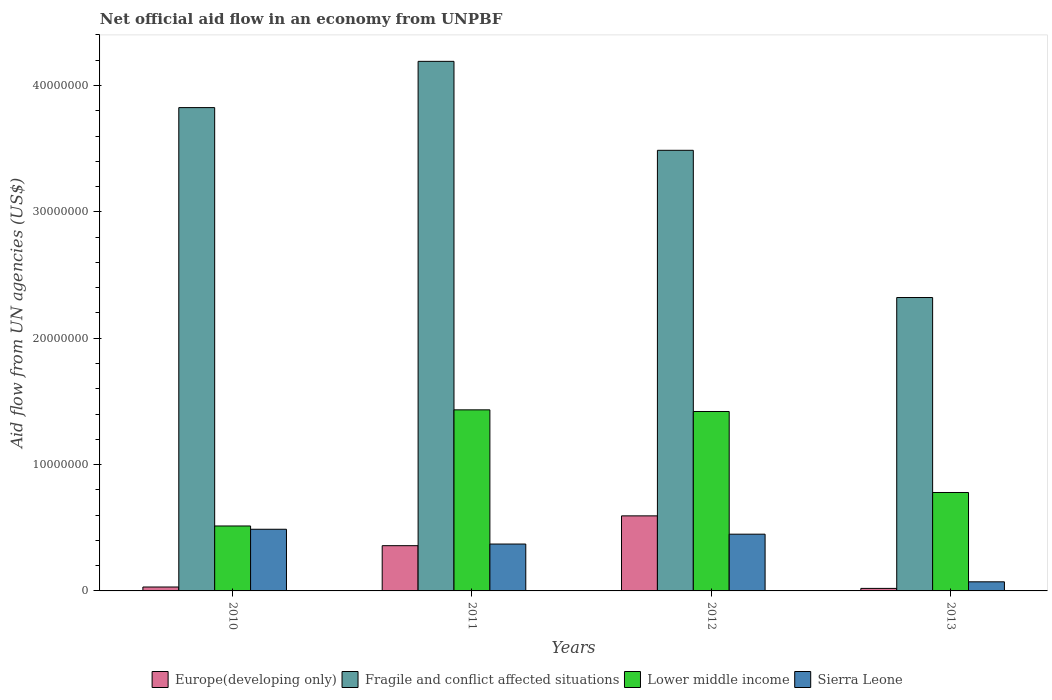How many bars are there on the 1st tick from the right?
Offer a terse response. 4. What is the label of the 4th group of bars from the left?
Offer a terse response. 2013. In how many cases, is the number of bars for a given year not equal to the number of legend labels?
Offer a very short reply. 0. What is the net official aid flow in Lower middle income in 2012?
Ensure brevity in your answer.  1.42e+07. Across all years, what is the maximum net official aid flow in Sierra Leone?
Give a very brief answer. 4.88e+06. Across all years, what is the minimum net official aid flow in Fragile and conflict affected situations?
Make the answer very short. 2.32e+07. What is the total net official aid flow in Lower middle income in the graph?
Make the answer very short. 4.15e+07. What is the difference between the net official aid flow in Lower middle income in 2011 and that in 2013?
Keep it short and to the point. 6.54e+06. What is the difference between the net official aid flow in Europe(developing only) in 2011 and the net official aid flow in Fragile and conflict affected situations in 2010?
Provide a succinct answer. -3.47e+07. What is the average net official aid flow in Fragile and conflict affected situations per year?
Make the answer very short. 3.46e+07. In the year 2013, what is the difference between the net official aid flow in Europe(developing only) and net official aid flow in Sierra Leone?
Offer a terse response. -5.20e+05. In how many years, is the net official aid flow in Sierra Leone greater than 32000000 US$?
Offer a very short reply. 0. What is the ratio of the net official aid flow in Lower middle income in 2012 to that in 2013?
Keep it short and to the point. 1.82. What is the difference between the highest and the lowest net official aid flow in Fragile and conflict affected situations?
Ensure brevity in your answer.  1.87e+07. In how many years, is the net official aid flow in Europe(developing only) greater than the average net official aid flow in Europe(developing only) taken over all years?
Your response must be concise. 2. What does the 2nd bar from the left in 2013 represents?
Your answer should be compact. Fragile and conflict affected situations. What does the 1st bar from the right in 2011 represents?
Keep it short and to the point. Sierra Leone. Is it the case that in every year, the sum of the net official aid flow in Fragile and conflict affected situations and net official aid flow in Sierra Leone is greater than the net official aid flow in Lower middle income?
Provide a succinct answer. Yes. How many bars are there?
Provide a succinct answer. 16. Are all the bars in the graph horizontal?
Offer a very short reply. No. How many years are there in the graph?
Your answer should be very brief. 4. Does the graph contain any zero values?
Provide a short and direct response. No. Does the graph contain grids?
Keep it short and to the point. No. Where does the legend appear in the graph?
Offer a very short reply. Bottom center. How many legend labels are there?
Give a very brief answer. 4. What is the title of the graph?
Your response must be concise. Net official aid flow in an economy from UNPBF. What is the label or title of the Y-axis?
Offer a very short reply. Aid flow from UN agencies (US$). What is the Aid flow from UN agencies (US$) in Fragile and conflict affected situations in 2010?
Make the answer very short. 3.82e+07. What is the Aid flow from UN agencies (US$) in Lower middle income in 2010?
Your response must be concise. 5.14e+06. What is the Aid flow from UN agencies (US$) of Sierra Leone in 2010?
Keep it short and to the point. 4.88e+06. What is the Aid flow from UN agencies (US$) in Europe(developing only) in 2011?
Offer a terse response. 3.58e+06. What is the Aid flow from UN agencies (US$) of Fragile and conflict affected situations in 2011?
Your response must be concise. 4.19e+07. What is the Aid flow from UN agencies (US$) in Lower middle income in 2011?
Your answer should be very brief. 1.43e+07. What is the Aid flow from UN agencies (US$) in Sierra Leone in 2011?
Provide a short and direct response. 3.71e+06. What is the Aid flow from UN agencies (US$) in Europe(developing only) in 2012?
Keep it short and to the point. 5.94e+06. What is the Aid flow from UN agencies (US$) in Fragile and conflict affected situations in 2012?
Provide a short and direct response. 3.49e+07. What is the Aid flow from UN agencies (US$) in Lower middle income in 2012?
Keep it short and to the point. 1.42e+07. What is the Aid flow from UN agencies (US$) in Sierra Leone in 2012?
Your answer should be compact. 4.49e+06. What is the Aid flow from UN agencies (US$) of Fragile and conflict affected situations in 2013?
Your answer should be very brief. 2.32e+07. What is the Aid flow from UN agencies (US$) in Lower middle income in 2013?
Keep it short and to the point. 7.79e+06. What is the Aid flow from UN agencies (US$) in Sierra Leone in 2013?
Your answer should be compact. 7.20e+05. Across all years, what is the maximum Aid flow from UN agencies (US$) of Europe(developing only)?
Offer a terse response. 5.94e+06. Across all years, what is the maximum Aid flow from UN agencies (US$) of Fragile and conflict affected situations?
Your response must be concise. 4.19e+07. Across all years, what is the maximum Aid flow from UN agencies (US$) in Lower middle income?
Your response must be concise. 1.43e+07. Across all years, what is the maximum Aid flow from UN agencies (US$) in Sierra Leone?
Offer a terse response. 4.88e+06. Across all years, what is the minimum Aid flow from UN agencies (US$) in Europe(developing only)?
Keep it short and to the point. 2.00e+05. Across all years, what is the minimum Aid flow from UN agencies (US$) in Fragile and conflict affected situations?
Your answer should be compact. 2.32e+07. Across all years, what is the minimum Aid flow from UN agencies (US$) in Lower middle income?
Provide a succinct answer. 5.14e+06. Across all years, what is the minimum Aid flow from UN agencies (US$) of Sierra Leone?
Offer a terse response. 7.20e+05. What is the total Aid flow from UN agencies (US$) in Europe(developing only) in the graph?
Your answer should be very brief. 1.00e+07. What is the total Aid flow from UN agencies (US$) of Fragile and conflict affected situations in the graph?
Make the answer very short. 1.38e+08. What is the total Aid flow from UN agencies (US$) of Lower middle income in the graph?
Make the answer very short. 4.15e+07. What is the total Aid flow from UN agencies (US$) of Sierra Leone in the graph?
Ensure brevity in your answer.  1.38e+07. What is the difference between the Aid flow from UN agencies (US$) in Europe(developing only) in 2010 and that in 2011?
Ensure brevity in your answer.  -3.27e+06. What is the difference between the Aid flow from UN agencies (US$) of Fragile and conflict affected situations in 2010 and that in 2011?
Offer a very short reply. -3.66e+06. What is the difference between the Aid flow from UN agencies (US$) of Lower middle income in 2010 and that in 2011?
Give a very brief answer. -9.19e+06. What is the difference between the Aid flow from UN agencies (US$) of Sierra Leone in 2010 and that in 2011?
Ensure brevity in your answer.  1.17e+06. What is the difference between the Aid flow from UN agencies (US$) in Europe(developing only) in 2010 and that in 2012?
Ensure brevity in your answer.  -5.63e+06. What is the difference between the Aid flow from UN agencies (US$) in Fragile and conflict affected situations in 2010 and that in 2012?
Your answer should be very brief. 3.38e+06. What is the difference between the Aid flow from UN agencies (US$) in Lower middle income in 2010 and that in 2012?
Ensure brevity in your answer.  -9.06e+06. What is the difference between the Aid flow from UN agencies (US$) in Europe(developing only) in 2010 and that in 2013?
Keep it short and to the point. 1.10e+05. What is the difference between the Aid flow from UN agencies (US$) in Fragile and conflict affected situations in 2010 and that in 2013?
Your response must be concise. 1.50e+07. What is the difference between the Aid flow from UN agencies (US$) of Lower middle income in 2010 and that in 2013?
Offer a very short reply. -2.65e+06. What is the difference between the Aid flow from UN agencies (US$) in Sierra Leone in 2010 and that in 2013?
Give a very brief answer. 4.16e+06. What is the difference between the Aid flow from UN agencies (US$) in Europe(developing only) in 2011 and that in 2012?
Provide a short and direct response. -2.36e+06. What is the difference between the Aid flow from UN agencies (US$) in Fragile and conflict affected situations in 2011 and that in 2012?
Make the answer very short. 7.04e+06. What is the difference between the Aid flow from UN agencies (US$) of Lower middle income in 2011 and that in 2012?
Your answer should be compact. 1.30e+05. What is the difference between the Aid flow from UN agencies (US$) in Sierra Leone in 2011 and that in 2012?
Offer a very short reply. -7.80e+05. What is the difference between the Aid flow from UN agencies (US$) of Europe(developing only) in 2011 and that in 2013?
Make the answer very short. 3.38e+06. What is the difference between the Aid flow from UN agencies (US$) in Fragile and conflict affected situations in 2011 and that in 2013?
Your response must be concise. 1.87e+07. What is the difference between the Aid flow from UN agencies (US$) of Lower middle income in 2011 and that in 2013?
Offer a very short reply. 6.54e+06. What is the difference between the Aid flow from UN agencies (US$) in Sierra Leone in 2011 and that in 2013?
Offer a terse response. 2.99e+06. What is the difference between the Aid flow from UN agencies (US$) of Europe(developing only) in 2012 and that in 2013?
Make the answer very short. 5.74e+06. What is the difference between the Aid flow from UN agencies (US$) in Fragile and conflict affected situations in 2012 and that in 2013?
Give a very brief answer. 1.16e+07. What is the difference between the Aid flow from UN agencies (US$) of Lower middle income in 2012 and that in 2013?
Your answer should be very brief. 6.41e+06. What is the difference between the Aid flow from UN agencies (US$) of Sierra Leone in 2012 and that in 2013?
Your answer should be very brief. 3.77e+06. What is the difference between the Aid flow from UN agencies (US$) in Europe(developing only) in 2010 and the Aid flow from UN agencies (US$) in Fragile and conflict affected situations in 2011?
Your answer should be compact. -4.16e+07. What is the difference between the Aid flow from UN agencies (US$) in Europe(developing only) in 2010 and the Aid flow from UN agencies (US$) in Lower middle income in 2011?
Your answer should be compact. -1.40e+07. What is the difference between the Aid flow from UN agencies (US$) of Europe(developing only) in 2010 and the Aid flow from UN agencies (US$) of Sierra Leone in 2011?
Your answer should be compact. -3.40e+06. What is the difference between the Aid flow from UN agencies (US$) of Fragile and conflict affected situations in 2010 and the Aid flow from UN agencies (US$) of Lower middle income in 2011?
Ensure brevity in your answer.  2.39e+07. What is the difference between the Aid flow from UN agencies (US$) in Fragile and conflict affected situations in 2010 and the Aid flow from UN agencies (US$) in Sierra Leone in 2011?
Offer a very short reply. 3.45e+07. What is the difference between the Aid flow from UN agencies (US$) in Lower middle income in 2010 and the Aid flow from UN agencies (US$) in Sierra Leone in 2011?
Your answer should be compact. 1.43e+06. What is the difference between the Aid flow from UN agencies (US$) in Europe(developing only) in 2010 and the Aid flow from UN agencies (US$) in Fragile and conflict affected situations in 2012?
Your answer should be compact. -3.46e+07. What is the difference between the Aid flow from UN agencies (US$) of Europe(developing only) in 2010 and the Aid flow from UN agencies (US$) of Lower middle income in 2012?
Keep it short and to the point. -1.39e+07. What is the difference between the Aid flow from UN agencies (US$) of Europe(developing only) in 2010 and the Aid flow from UN agencies (US$) of Sierra Leone in 2012?
Ensure brevity in your answer.  -4.18e+06. What is the difference between the Aid flow from UN agencies (US$) in Fragile and conflict affected situations in 2010 and the Aid flow from UN agencies (US$) in Lower middle income in 2012?
Provide a short and direct response. 2.40e+07. What is the difference between the Aid flow from UN agencies (US$) in Fragile and conflict affected situations in 2010 and the Aid flow from UN agencies (US$) in Sierra Leone in 2012?
Ensure brevity in your answer.  3.38e+07. What is the difference between the Aid flow from UN agencies (US$) of Lower middle income in 2010 and the Aid flow from UN agencies (US$) of Sierra Leone in 2012?
Ensure brevity in your answer.  6.50e+05. What is the difference between the Aid flow from UN agencies (US$) of Europe(developing only) in 2010 and the Aid flow from UN agencies (US$) of Fragile and conflict affected situations in 2013?
Your answer should be very brief. -2.29e+07. What is the difference between the Aid flow from UN agencies (US$) in Europe(developing only) in 2010 and the Aid flow from UN agencies (US$) in Lower middle income in 2013?
Keep it short and to the point. -7.48e+06. What is the difference between the Aid flow from UN agencies (US$) in Europe(developing only) in 2010 and the Aid flow from UN agencies (US$) in Sierra Leone in 2013?
Make the answer very short. -4.10e+05. What is the difference between the Aid flow from UN agencies (US$) in Fragile and conflict affected situations in 2010 and the Aid flow from UN agencies (US$) in Lower middle income in 2013?
Your response must be concise. 3.05e+07. What is the difference between the Aid flow from UN agencies (US$) in Fragile and conflict affected situations in 2010 and the Aid flow from UN agencies (US$) in Sierra Leone in 2013?
Offer a very short reply. 3.75e+07. What is the difference between the Aid flow from UN agencies (US$) of Lower middle income in 2010 and the Aid flow from UN agencies (US$) of Sierra Leone in 2013?
Keep it short and to the point. 4.42e+06. What is the difference between the Aid flow from UN agencies (US$) of Europe(developing only) in 2011 and the Aid flow from UN agencies (US$) of Fragile and conflict affected situations in 2012?
Offer a very short reply. -3.13e+07. What is the difference between the Aid flow from UN agencies (US$) of Europe(developing only) in 2011 and the Aid flow from UN agencies (US$) of Lower middle income in 2012?
Your answer should be very brief. -1.06e+07. What is the difference between the Aid flow from UN agencies (US$) in Europe(developing only) in 2011 and the Aid flow from UN agencies (US$) in Sierra Leone in 2012?
Give a very brief answer. -9.10e+05. What is the difference between the Aid flow from UN agencies (US$) in Fragile and conflict affected situations in 2011 and the Aid flow from UN agencies (US$) in Lower middle income in 2012?
Your response must be concise. 2.77e+07. What is the difference between the Aid flow from UN agencies (US$) in Fragile and conflict affected situations in 2011 and the Aid flow from UN agencies (US$) in Sierra Leone in 2012?
Provide a succinct answer. 3.74e+07. What is the difference between the Aid flow from UN agencies (US$) in Lower middle income in 2011 and the Aid flow from UN agencies (US$) in Sierra Leone in 2012?
Your response must be concise. 9.84e+06. What is the difference between the Aid flow from UN agencies (US$) in Europe(developing only) in 2011 and the Aid flow from UN agencies (US$) in Fragile and conflict affected situations in 2013?
Your response must be concise. -1.96e+07. What is the difference between the Aid flow from UN agencies (US$) of Europe(developing only) in 2011 and the Aid flow from UN agencies (US$) of Lower middle income in 2013?
Keep it short and to the point. -4.21e+06. What is the difference between the Aid flow from UN agencies (US$) in Europe(developing only) in 2011 and the Aid flow from UN agencies (US$) in Sierra Leone in 2013?
Ensure brevity in your answer.  2.86e+06. What is the difference between the Aid flow from UN agencies (US$) of Fragile and conflict affected situations in 2011 and the Aid flow from UN agencies (US$) of Lower middle income in 2013?
Your answer should be very brief. 3.41e+07. What is the difference between the Aid flow from UN agencies (US$) of Fragile and conflict affected situations in 2011 and the Aid flow from UN agencies (US$) of Sierra Leone in 2013?
Your answer should be very brief. 4.12e+07. What is the difference between the Aid flow from UN agencies (US$) in Lower middle income in 2011 and the Aid flow from UN agencies (US$) in Sierra Leone in 2013?
Give a very brief answer. 1.36e+07. What is the difference between the Aid flow from UN agencies (US$) of Europe(developing only) in 2012 and the Aid flow from UN agencies (US$) of Fragile and conflict affected situations in 2013?
Give a very brief answer. -1.73e+07. What is the difference between the Aid flow from UN agencies (US$) of Europe(developing only) in 2012 and the Aid flow from UN agencies (US$) of Lower middle income in 2013?
Offer a terse response. -1.85e+06. What is the difference between the Aid flow from UN agencies (US$) in Europe(developing only) in 2012 and the Aid flow from UN agencies (US$) in Sierra Leone in 2013?
Your answer should be very brief. 5.22e+06. What is the difference between the Aid flow from UN agencies (US$) in Fragile and conflict affected situations in 2012 and the Aid flow from UN agencies (US$) in Lower middle income in 2013?
Ensure brevity in your answer.  2.71e+07. What is the difference between the Aid flow from UN agencies (US$) of Fragile and conflict affected situations in 2012 and the Aid flow from UN agencies (US$) of Sierra Leone in 2013?
Ensure brevity in your answer.  3.42e+07. What is the difference between the Aid flow from UN agencies (US$) in Lower middle income in 2012 and the Aid flow from UN agencies (US$) in Sierra Leone in 2013?
Ensure brevity in your answer.  1.35e+07. What is the average Aid flow from UN agencies (US$) in Europe(developing only) per year?
Offer a very short reply. 2.51e+06. What is the average Aid flow from UN agencies (US$) of Fragile and conflict affected situations per year?
Your answer should be very brief. 3.46e+07. What is the average Aid flow from UN agencies (US$) in Lower middle income per year?
Offer a very short reply. 1.04e+07. What is the average Aid flow from UN agencies (US$) in Sierra Leone per year?
Your answer should be very brief. 3.45e+06. In the year 2010, what is the difference between the Aid flow from UN agencies (US$) of Europe(developing only) and Aid flow from UN agencies (US$) of Fragile and conflict affected situations?
Your answer should be very brief. -3.79e+07. In the year 2010, what is the difference between the Aid flow from UN agencies (US$) of Europe(developing only) and Aid flow from UN agencies (US$) of Lower middle income?
Your answer should be compact. -4.83e+06. In the year 2010, what is the difference between the Aid flow from UN agencies (US$) of Europe(developing only) and Aid flow from UN agencies (US$) of Sierra Leone?
Your answer should be compact. -4.57e+06. In the year 2010, what is the difference between the Aid flow from UN agencies (US$) of Fragile and conflict affected situations and Aid flow from UN agencies (US$) of Lower middle income?
Provide a short and direct response. 3.31e+07. In the year 2010, what is the difference between the Aid flow from UN agencies (US$) in Fragile and conflict affected situations and Aid flow from UN agencies (US$) in Sierra Leone?
Offer a very short reply. 3.34e+07. In the year 2010, what is the difference between the Aid flow from UN agencies (US$) in Lower middle income and Aid flow from UN agencies (US$) in Sierra Leone?
Ensure brevity in your answer.  2.60e+05. In the year 2011, what is the difference between the Aid flow from UN agencies (US$) of Europe(developing only) and Aid flow from UN agencies (US$) of Fragile and conflict affected situations?
Provide a succinct answer. -3.83e+07. In the year 2011, what is the difference between the Aid flow from UN agencies (US$) of Europe(developing only) and Aid flow from UN agencies (US$) of Lower middle income?
Provide a succinct answer. -1.08e+07. In the year 2011, what is the difference between the Aid flow from UN agencies (US$) in Europe(developing only) and Aid flow from UN agencies (US$) in Sierra Leone?
Make the answer very short. -1.30e+05. In the year 2011, what is the difference between the Aid flow from UN agencies (US$) in Fragile and conflict affected situations and Aid flow from UN agencies (US$) in Lower middle income?
Give a very brief answer. 2.76e+07. In the year 2011, what is the difference between the Aid flow from UN agencies (US$) in Fragile and conflict affected situations and Aid flow from UN agencies (US$) in Sierra Leone?
Give a very brief answer. 3.82e+07. In the year 2011, what is the difference between the Aid flow from UN agencies (US$) of Lower middle income and Aid flow from UN agencies (US$) of Sierra Leone?
Make the answer very short. 1.06e+07. In the year 2012, what is the difference between the Aid flow from UN agencies (US$) in Europe(developing only) and Aid flow from UN agencies (US$) in Fragile and conflict affected situations?
Your answer should be compact. -2.89e+07. In the year 2012, what is the difference between the Aid flow from UN agencies (US$) of Europe(developing only) and Aid flow from UN agencies (US$) of Lower middle income?
Give a very brief answer. -8.26e+06. In the year 2012, what is the difference between the Aid flow from UN agencies (US$) in Europe(developing only) and Aid flow from UN agencies (US$) in Sierra Leone?
Your answer should be very brief. 1.45e+06. In the year 2012, what is the difference between the Aid flow from UN agencies (US$) in Fragile and conflict affected situations and Aid flow from UN agencies (US$) in Lower middle income?
Give a very brief answer. 2.07e+07. In the year 2012, what is the difference between the Aid flow from UN agencies (US$) in Fragile and conflict affected situations and Aid flow from UN agencies (US$) in Sierra Leone?
Ensure brevity in your answer.  3.04e+07. In the year 2012, what is the difference between the Aid flow from UN agencies (US$) in Lower middle income and Aid flow from UN agencies (US$) in Sierra Leone?
Provide a succinct answer. 9.71e+06. In the year 2013, what is the difference between the Aid flow from UN agencies (US$) in Europe(developing only) and Aid flow from UN agencies (US$) in Fragile and conflict affected situations?
Provide a short and direct response. -2.30e+07. In the year 2013, what is the difference between the Aid flow from UN agencies (US$) of Europe(developing only) and Aid flow from UN agencies (US$) of Lower middle income?
Your answer should be very brief. -7.59e+06. In the year 2013, what is the difference between the Aid flow from UN agencies (US$) of Europe(developing only) and Aid flow from UN agencies (US$) of Sierra Leone?
Your answer should be very brief. -5.20e+05. In the year 2013, what is the difference between the Aid flow from UN agencies (US$) of Fragile and conflict affected situations and Aid flow from UN agencies (US$) of Lower middle income?
Give a very brief answer. 1.54e+07. In the year 2013, what is the difference between the Aid flow from UN agencies (US$) of Fragile and conflict affected situations and Aid flow from UN agencies (US$) of Sierra Leone?
Your answer should be compact. 2.25e+07. In the year 2013, what is the difference between the Aid flow from UN agencies (US$) of Lower middle income and Aid flow from UN agencies (US$) of Sierra Leone?
Your answer should be compact. 7.07e+06. What is the ratio of the Aid flow from UN agencies (US$) of Europe(developing only) in 2010 to that in 2011?
Your response must be concise. 0.09. What is the ratio of the Aid flow from UN agencies (US$) in Fragile and conflict affected situations in 2010 to that in 2011?
Offer a terse response. 0.91. What is the ratio of the Aid flow from UN agencies (US$) in Lower middle income in 2010 to that in 2011?
Make the answer very short. 0.36. What is the ratio of the Aid flow from UN agencies (US$) in Sierra Leone in 2010 to that in 2011?
Make the answer very short. 1.32. What is the ratio of the Aid flow from UN agencies (US$) of Europe(developing only) in 2010 to that in 2012?
Keep it short and to the point. 0.05. What is the ratio of the Aid flow from UN agencies (US$) in Fragile and conflict affected situations in 2010 to that in 2012?
Offer a very short reply. 1.1. What is the ratio of the Aid flow from UN agencies (US$) of Lower middle income in 2010 to that in 2012?
Keep it short and to the point. 0.36. What is the ratio of the Aid flow from UN agencies (US$) of Sierra Leone in 2010 to that in 2012?
Provide a short and direct response. 1.09. What is the ratio of the Aid flow from UN agencies (US$) in Europe(developing only) in 2010 to that in 2013?
Your response must be concise. 1.55. What is the ratio of the Aid flow from UN agencies (US$) of Fragile and conflict affected situations in 2010 to that in 2013?
Ensure brevity in your answer.  1.65. What is the ratio of the Aid flow from UN agencies (US$) of Lower middle income in 2010 to that in 2013?
Your answer should be very brief. 0.66. What is the ratio of the Aid flow from UN agencies (US$) in Sierra Leone in 2010 to that in 2013?
Provide a succinct answer. 6.78. What is the ratio of the Aid flow from UN agencies (US$) of Europe(developing only) in 2011 to that in 2012?
Give a very brief answer. 0.6. What is the ratio of the Aid flow from UN agencies (US$) in Fragile and conflict affected situations in 2011 to that in 2012?
Offer a terse response. 1.2. What is the ratio of the Aid flow from UN agencies (US$) in Lower middle income in 2011 to that in 2012?
Your answer should be very brief. 1.01. What is the ratio of the Aid flow from UN agencies (US$) in Sierra Leone in 2011 to that in 2012?
Your answer should be very brief. 0.83. What is the ratio of the Aid flow from UN agencies (US$) of Europe(developing only) in 2011 to that in 2013?
Your answer should be compact. 17.9. What is the ratio of the Aid flow from UN agencies (US$) in Fragile and conflict affected situations in 2011 to that in 2013?
Offer a very short reply. 1.8. What is the ratio of the Aid flow from UN agencies (US$) in Lower middle income in 2011 to that in 2013?
Provide a succinct answer. 1.84. What is the ratio of the Aid flow from UN agencies (US$) in Sierra Leone in 2011 to that in 2013?
Keep it short and to the point. 5.15. What is the ratio of the Aid flow from UN agencies (US$) of Europe(developing only) in 2012 to that in 2013?
Your answer should be compact. 29.7. What is the ratio of the Aid flow from UN agencies (US$) in Fragile and conflict affected situations in 2012 to that in 2013?
Keep it short and to the point. 1.5. What is the ratio of the Aid flow from UN agencies (US$) in Lower middle income in 2012 to that in 2013?
Make the answer very short. 1.82. What is the ratio of the Aid flow from UN agencies (US$) of Sierra Leone in 2012 to that in 2013?
Provide a succinct answer. 6.24. What is the difference between the highest and the second highest Aid flow from UN agencies (US$) in Europe(developing only)?
Provide a short and direct response. 2.36e+06. What is the difference between the highest and the second highest Aid flow from UN agencies (US$) in Fragile and conflict affected situations?
Ensure brevity in your answer.  3.66e+06. What is the difference between the highest and the second highest Aid flow from UN agencies (US$) of Sierra Leone?
Your answer should be compact. 3.90e+05. What is the difference between the highest and the lowest Aid flow from UN agencies (US$) in Europe(developing only)?
Give a very brief answer. 5.74e+06. What is the difference between the highest and the lowest Aid flow from UN agencies (US$) in Fragile and conflict affected situations?
Provide a short and direct response. 1.87e+07. What is the difference between the highest and the lowest Aid flow from UN agencies (US$) in Lower middle income?
Provide a succinct answer. 9.19e+06. What is the difference between the highest and the lowest Aid flow from UN agencies (US$) in Sierra Leone?
Make the answer very short. 4.16e+06. 